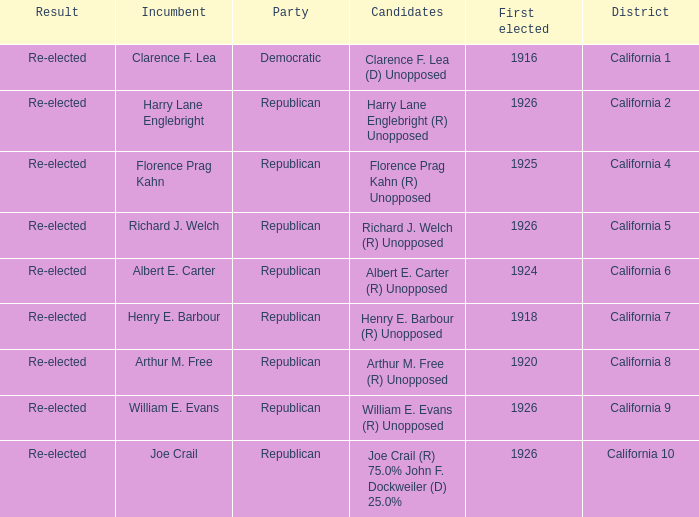What's the district with candidates being harry lane englebright (r) unopposed California 2. 